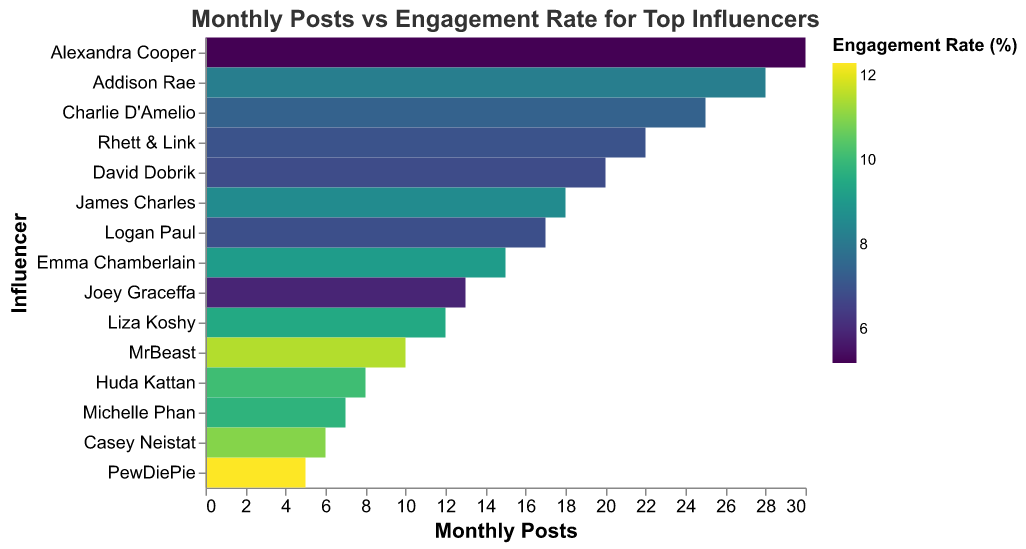How many influencers post at least 20 times a month? To find the answer, count the influencers with "Monthly Posts" greater than or equal to 20. This includes Alexandra Cooper (30), David Dobrik (20), Charlie D'Amelio (25), Addison Rae (28), and Rhett & Link (22).
Answer: 5 Which influencer has the highest engagement rate? Look at the "Engagement Rate" field and identify the highest value. PewDiePie has the highest engagement rate of 12.3%.
Answer: PewDiePie Is there a strong correlation between the number of monthly posts and the engagement rate? To answer, visually inspect the heatmap to see if higher monthly posts correspond to higher engagement rates. The heatmap shows no clear pattern indicating a strong correlation.
Answer: No Which influencer posts the least frequently but has a high engagement rate? Identify the influencer with the fewest monthly posts and check their engagement rate. PewDiePie posts 5 times a month with an engagement rate of 12.3%, which is high.
Answer: PewDiePie What's the average engagement rate of influencers posting more than 15 times a month? First, list the influencers posting more than 15 times a month: Alexandra Cooper (5.2), David Dobrik (6.8), Charlie D'Amelio (7.4), Addison Rae (8.2), Rhett & Link (7.0), James Charles (8.6), and Logan Paul (6.9). Sum their engagement rates: 5.2 + 6.8 + 7.4 + 8.2 + 7.0 + 8.6 + 6.9 = 50.1. Divide by the number of influencers: 50.1 / 7 = approximately 7.2.
Answer: 7.2 Which influencer with a monthly post frequency between 10 and 20 has the highest engagement rate? Identify influencers with "Monthly Posts" between 10 and 20: Liza Koshy (9.5), David Dobrik (6.8), Emma Chamberlain (9.1), James Charles (8.6), Logan Paul (6.9), Joey Graceffa (5.9). The highest engagement rate among them is Liza Koshy with 9.5%.
Answer: Liza Koshy How many influencers have an engagement rate of 10% or higher? Count the influencers with "Engagement Rate" 10% or higher. These include MrBeast (11.5), PewDiePie (12.3), Huda Kattan (10.1), Michelle Phan (9.8), and Casey Neistat (11.0).
Answer: 4 Which influencer with fewer than 10 monthly posts has the highest engagement rate? Identify influencers with fewer than 10 monthly posts: PewDiePie (12.3), Huda Kattan (10.1), Michelle Phan (9.8), Casey Neistat (11.0). The highest engagement rate among them is PewDiePie with 12.3%.
Answer: PewDiePie 